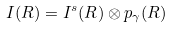Convert formula to latex. <formula><loc_0><loc_0><loc_500><loc_500>I ( R ) = I ^ { s } ( R ) \otimes p _ { \gamma } ( R )</formula> 